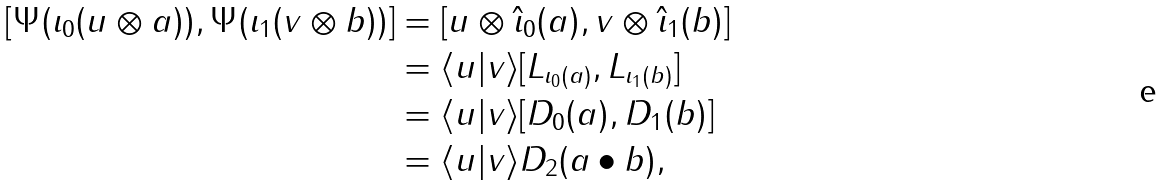Convert formula to latex. <formula><loc_0><loc_0><loc_500><loc_500>[ \Psi ( \iota _ { 0 } ( u \otimes a ) ) , \Psi ( \iota _ { 1 } ( v \otimes b ) ) ] & = [ u \otimes \hat { \iota } _ { 0 } ( a ) , v \otimes \hat { \iota } _ { 1 } ( b ) ] \\ & = \langle u | v \rangle [ L _ { \iota _ { 0 } ( a ) } , L _ { \iota _ { 1 } ( b ) } ] \\ & = \langle u | v \rangle [ D _ { 0 } ( a ) , D _ { 1 } ( b ) ] \\ & = \langle u | v \rangle D _ { 2 } ( a \bullet b ) ,</formula> 